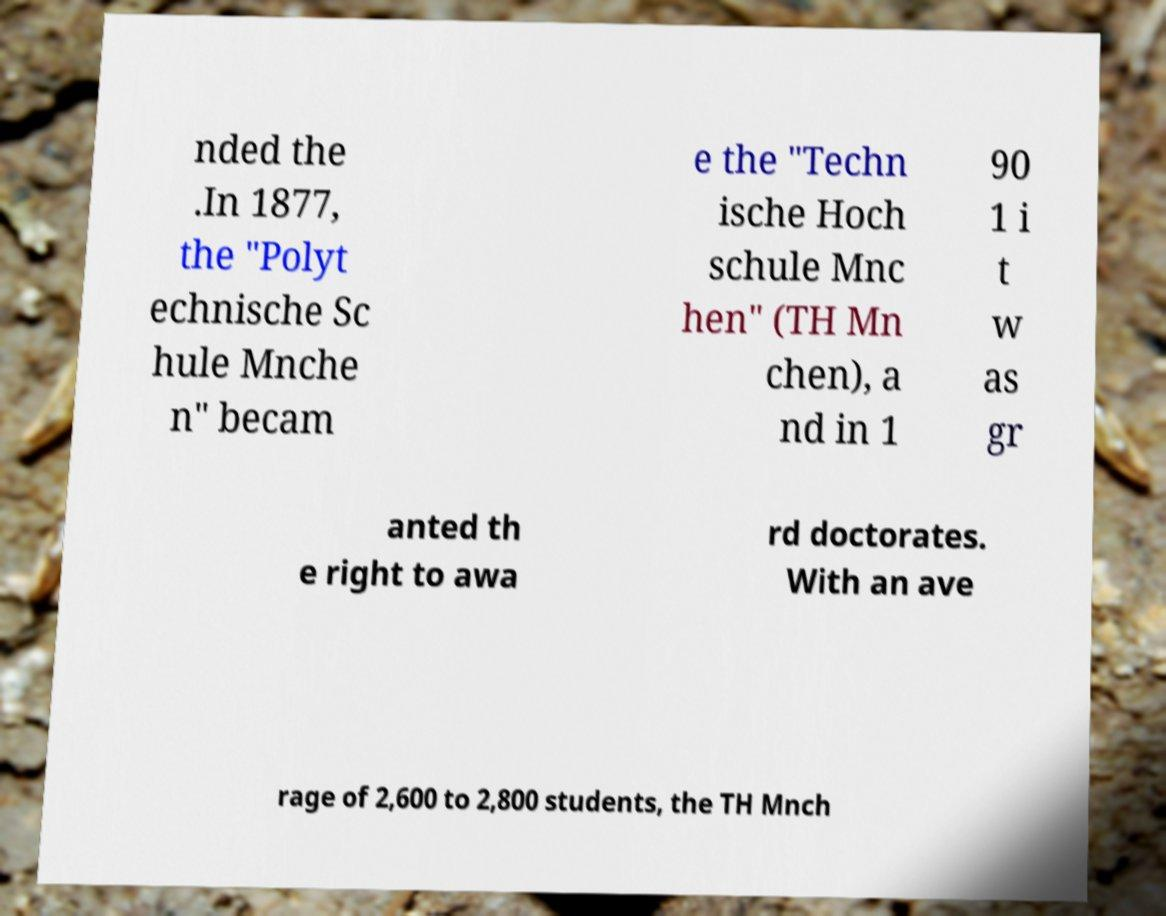Please read and relay the text visible in this image. What does it say? nded the .In 1877, the "Polyt echnische Sc hule Mnche n" becam e the "Techn ische Hoch schule Mnc hen" (TH Mn chen), a nd in 1 90 1 i t w as gr anted th e right to awa rd doctorates. With an ave rage of 2,600 to 2,800 students, the TH Mnch 